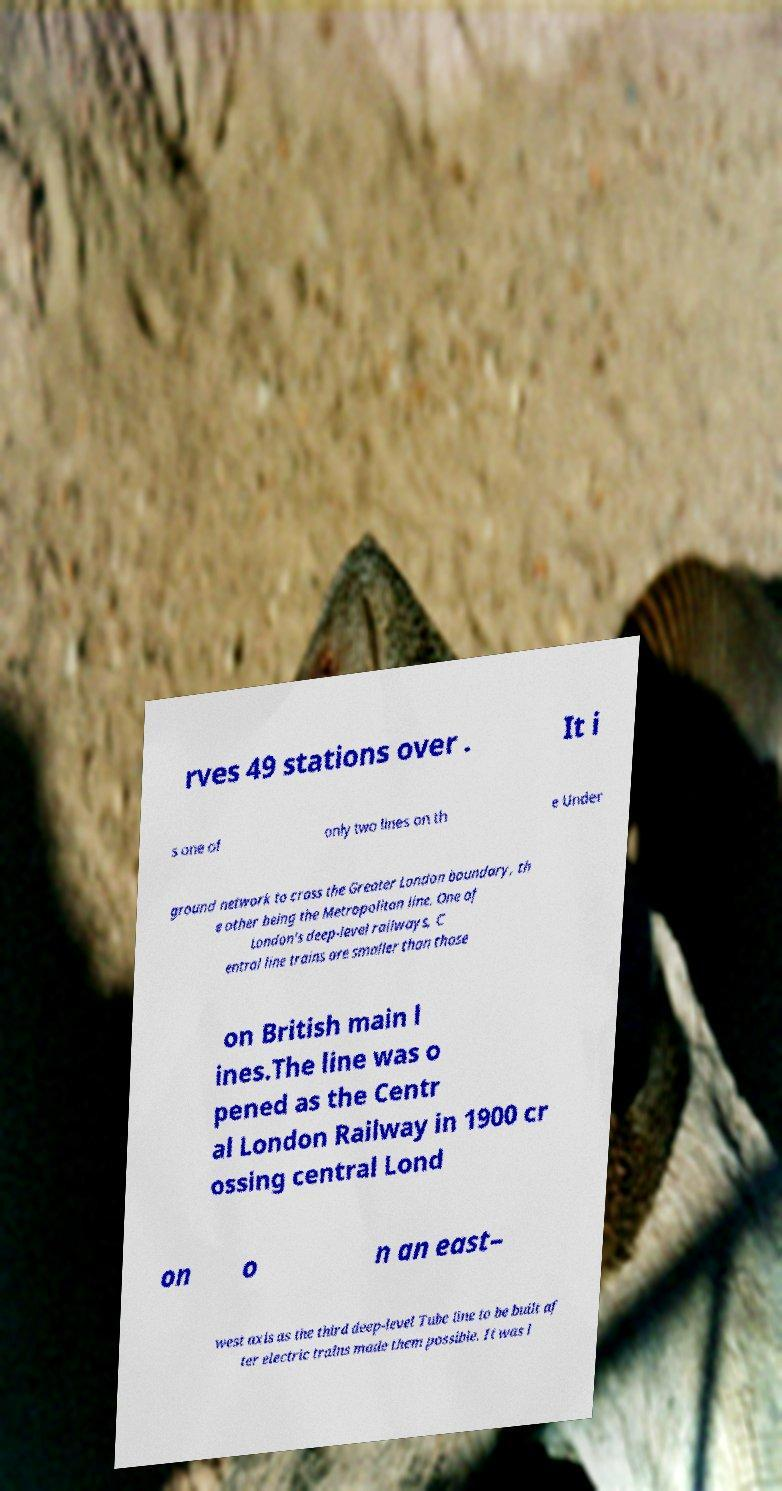Please read and relay the text visible in this image. What does it say? rves 49 stations over . It i s one of only two lines on th e Under ground network to cross the Greater London boundary, th e other being the Metropolitan line. One of London's deep-level railways, C entral line trains are smaller than those on British main l ines.The line was o pened as the Centr al London Railway in 1900 cr ossing central Lond on o n an east– west axis as the third deep-level Tube line to be built af ter electric trains made them possible. It was l 